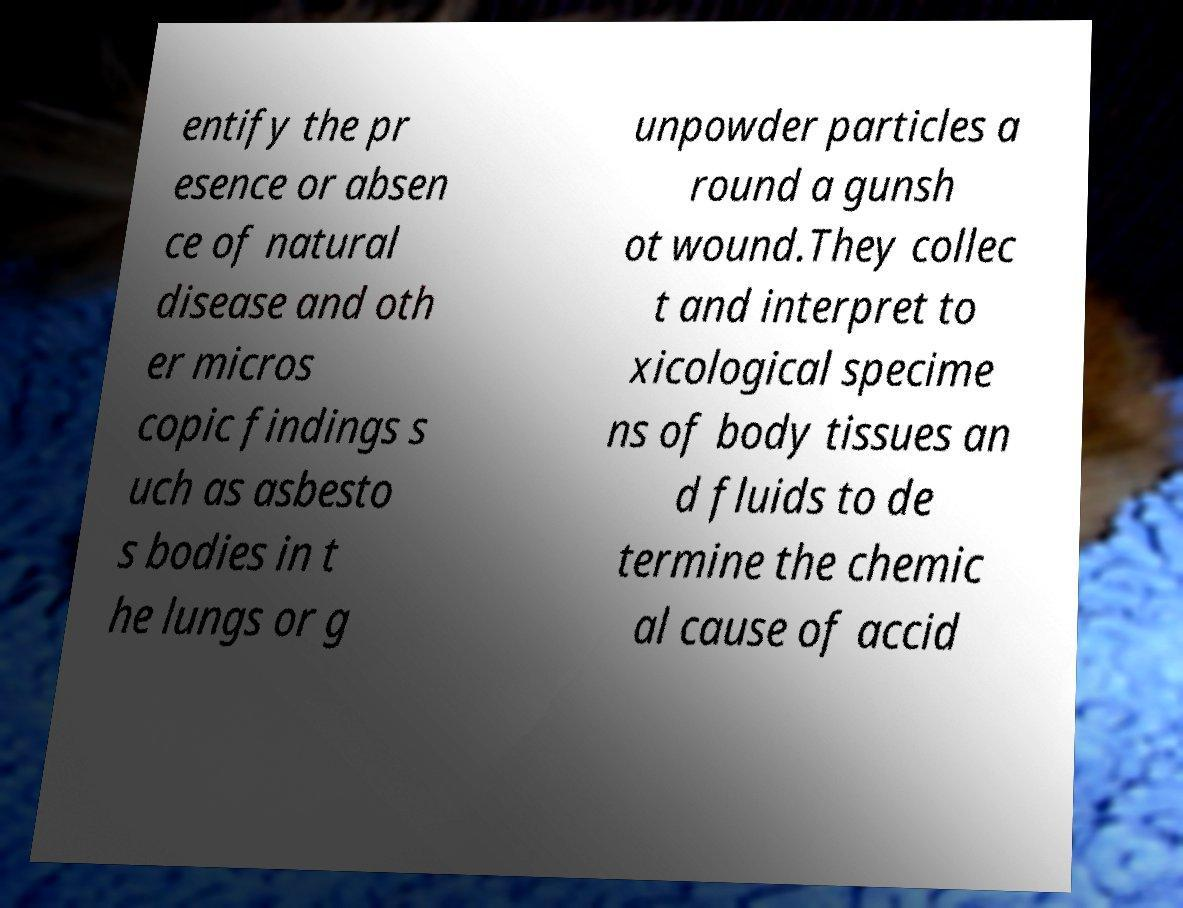Can you accurately transcribe the text from the provided image for me? entify the pr esence or absen ce of natural disease and oth er micros copic findings s uch as asbesto s bodies in t he lungs or g unpowder particles a round a gunsh ot wound.They collec t and interpret to xicological specime ns of body tissues an d fluids to de termine the chemic al cause of accid 